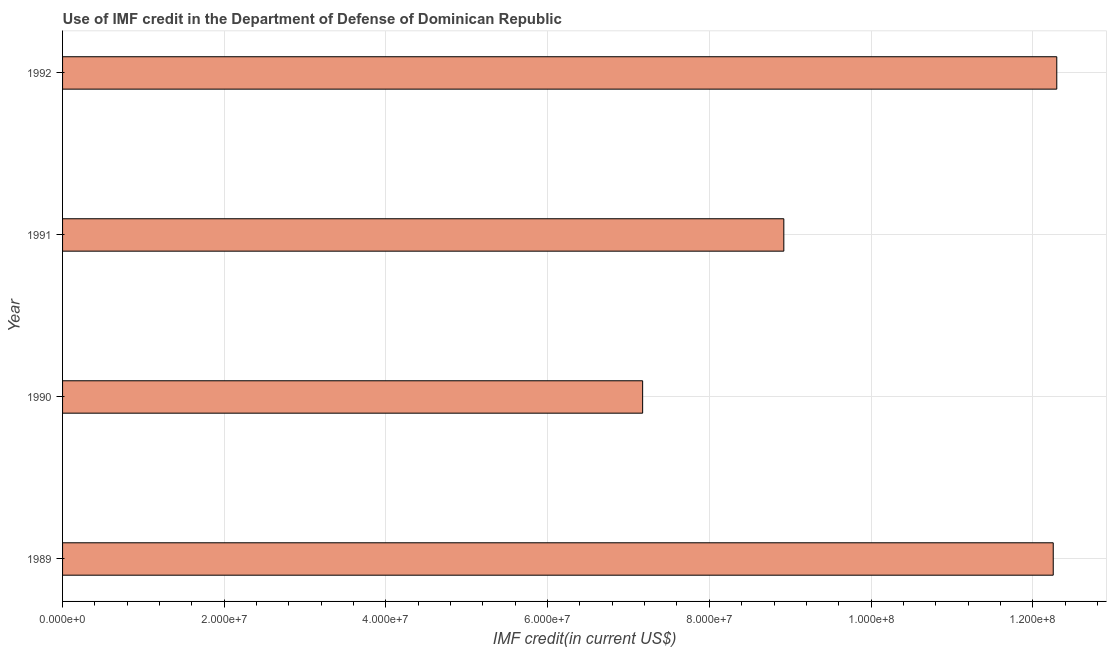Does the graph contain any zero values?
Ensure brevity in your answer.  No. Does the graph contain grids?
Your answer should be very brief. Yes. What is the title of the graph?
Ensure brevity in your answer.  Use of IMF credit in the Department of Defense of Dominican Republic. What is the label or title of the X-axis?
Keep it short and to the point. IMF credit(in current US$). What is the use of imf credit in dod in 1991?
Give a very brief answer. 8.92e+07. Across all years, what is the maximum use of imf credit in dod?
Keep it short and to the point. 1.23e+08. Across all years, what is the minimum use of imf credit in dod?
Offer a very short reply. 7.18e+07. What is the sum of the use of imf credit in dod?
Your answer should be very brief. 4.06e+08. What is the difference between the use of imf credit in dod in 1991 and 1992?
Your answer should be compact. -3.38e+07. What is the average use of imf credit in dod per year?
Offer a terse response. 1.02e+08. What is the median use of imf credit in dod?
Offer a very short reply. 1.06e+08. What is the ratio of the use of imf credit in dod in 1990 to that in 1991?
Offer a terse response. 0.8. What is the difference between the highest and the second highest use of imf credit in dod?
Provide a short and direct response. 4.38e+05. Is the sum of the use of imf credit in dod in 1989 and 1992 greater than the maximum use of imf credit in dod across all years?
Provide a short and direct response. Yes. What is the difference between the highest and the lowest use of imf credit in dod?
Your answer should be very brief. 5.12e+07. In how many years, is the use of imf credit in dod greater than the average use of imf credit in dod taken over all years?
Your answer should be very brief. 2. How many bars are there?
Your response must be concise. 4. How many years are there in the graph?
Your response must be concise. 4. What is the IMF credit(in current US$) in 1989?
Your answer should be very brief. 1.23e+08. What is the IMF credit(in current US$) of 1990?
Your answer should be very brief. 7.18e+07. What is the IMF credit(in current US$) of 1991?
Provide a short and direct response. 8.92e+07. What is the IMF credit(in current US$) of 1992?
Your answer should be compact. 1.23e+08. What is the difference between the IMF credit(in current US$) in 1989 and 1990?
Your response must be concise. 5.08e+07. What is the difference between the IMF credit(in current US$) in 1989 and 1991?
Offer a terse response. 3.33e+07. What is the difference between the IMF credit(in current US$) in 1989 and 1992?
Provide a succinct answer. -4.38e+05. What is the difference between the IMF credit(in current US$) in 1990 and 1991?
Your answer should be very brief. -1.75e+07. What is the difference between the IMF credit(in current US$) in 1990 and 1992?
Offer a very short reply. -5.12e+07. What is the difference between the IMF credit(in current US$) in 1991 and 1992?
Ensure brevity in your answer.  -3.38e+07. What is the ratio of the IMF credit(in current US$) in 1989 to that in 1990?
Provide a short and direct response. 1.71. What is the ratio of the IMF credit(in current US$) in 1989 to that in 1991?
Provide a short and direct response. 1.37. What is the ratio of the IMF credit(in current US$) in 1990 to that in 1991?
Ensure brevity in your answer.  0.8. What is the ratio of the IMF credit(in current US$) in 1990 to that in 1992?
Ensure brevity in your answer.  0.58. What is the ratio of the IMF credit(in current US$) in 1991 to that in 1992?
Ensure brevity in your answer.  0.72. 